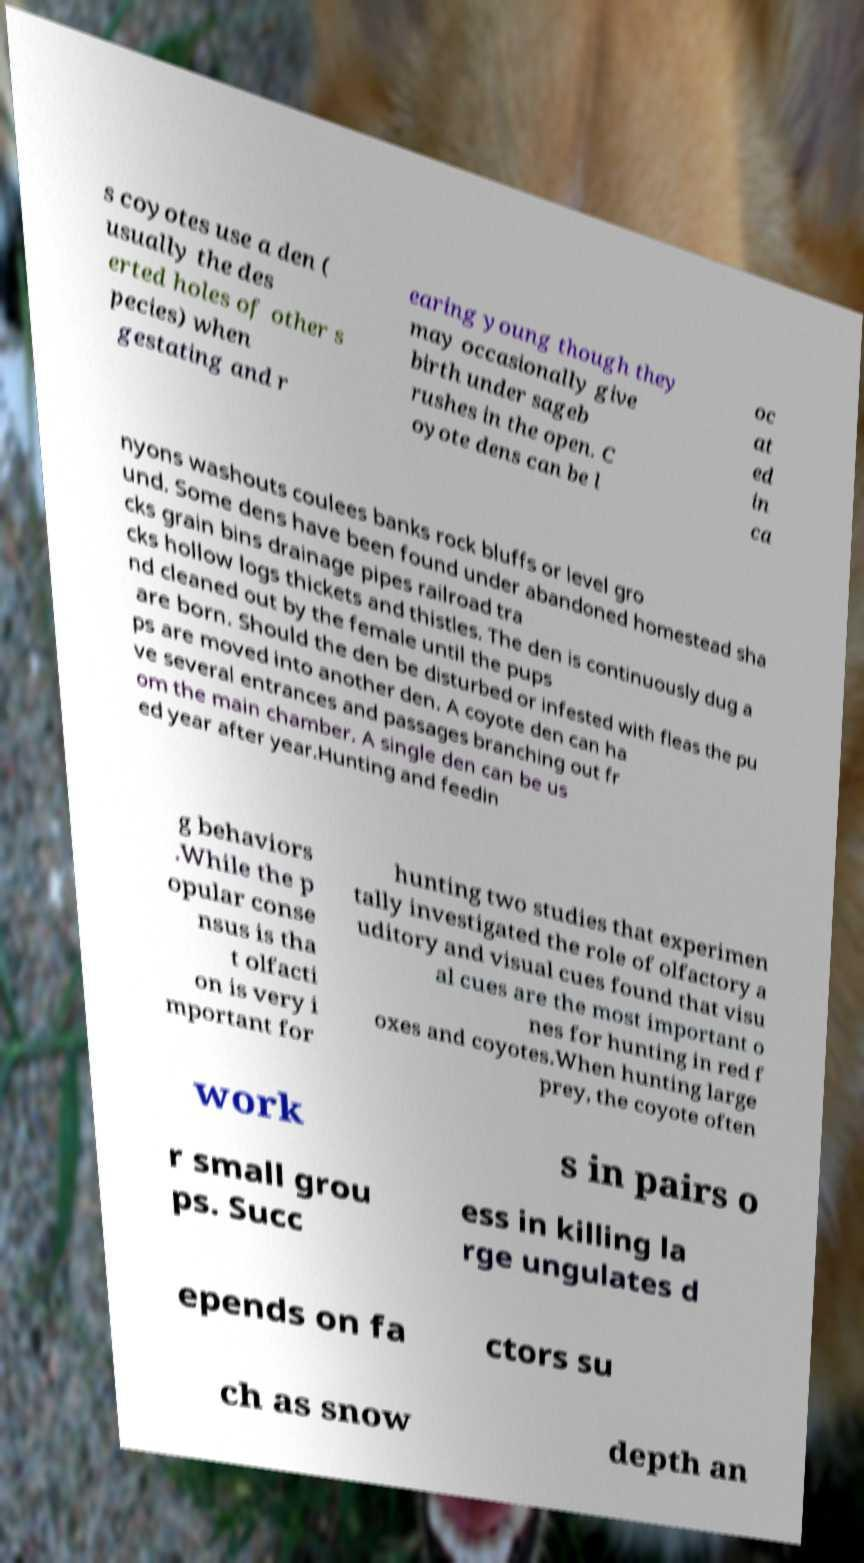Can you read and provide the text displayed in the image?This photo seems to have some interesting text. Can you extract and type it out for me? s coyotes use a den ( usually the des erted holes of other s pecies) when gestating and r earing young though they may occasionally give birth under sageb rushes in the open. C oyote dens can be l oc at ed in ca nyons washouts coulees banks rock bluffs or level gro und. Some dens have been found under abandoned homestead sha cks grain bins drainage pipes railroad tra cks hollow logs thickets and thistles. The den is continuously dug a nd cleaned out by the female until the pups are born. Should the den be disturbed or infested with fleas the pu ps are moved into another den. A coyote den can ha ve several entrances and passages branching out fr om the main chamber. A single den can be us ed year after year.Hunting and feedin g behaviors .While the p opular conse nsus is tha t olfacti on is very i mportant for hunting two studies that experimen tally investigated the role of olfactory a uditory and visual cues found that visu al cues are the most important o nes for hunting in red f oxes and coyotes.When hunting large prey, the coyote often work s in pairs o r small grou ps. Succ ess in killing la rge ungulates d epends on fa ctors su ch as snow depth an 